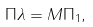Convert formula to latex. <formula><loc_0><loc_0><loc_500><loc_500>\Pi \lambda = M \Pi _ { 1 } ,</formula> 